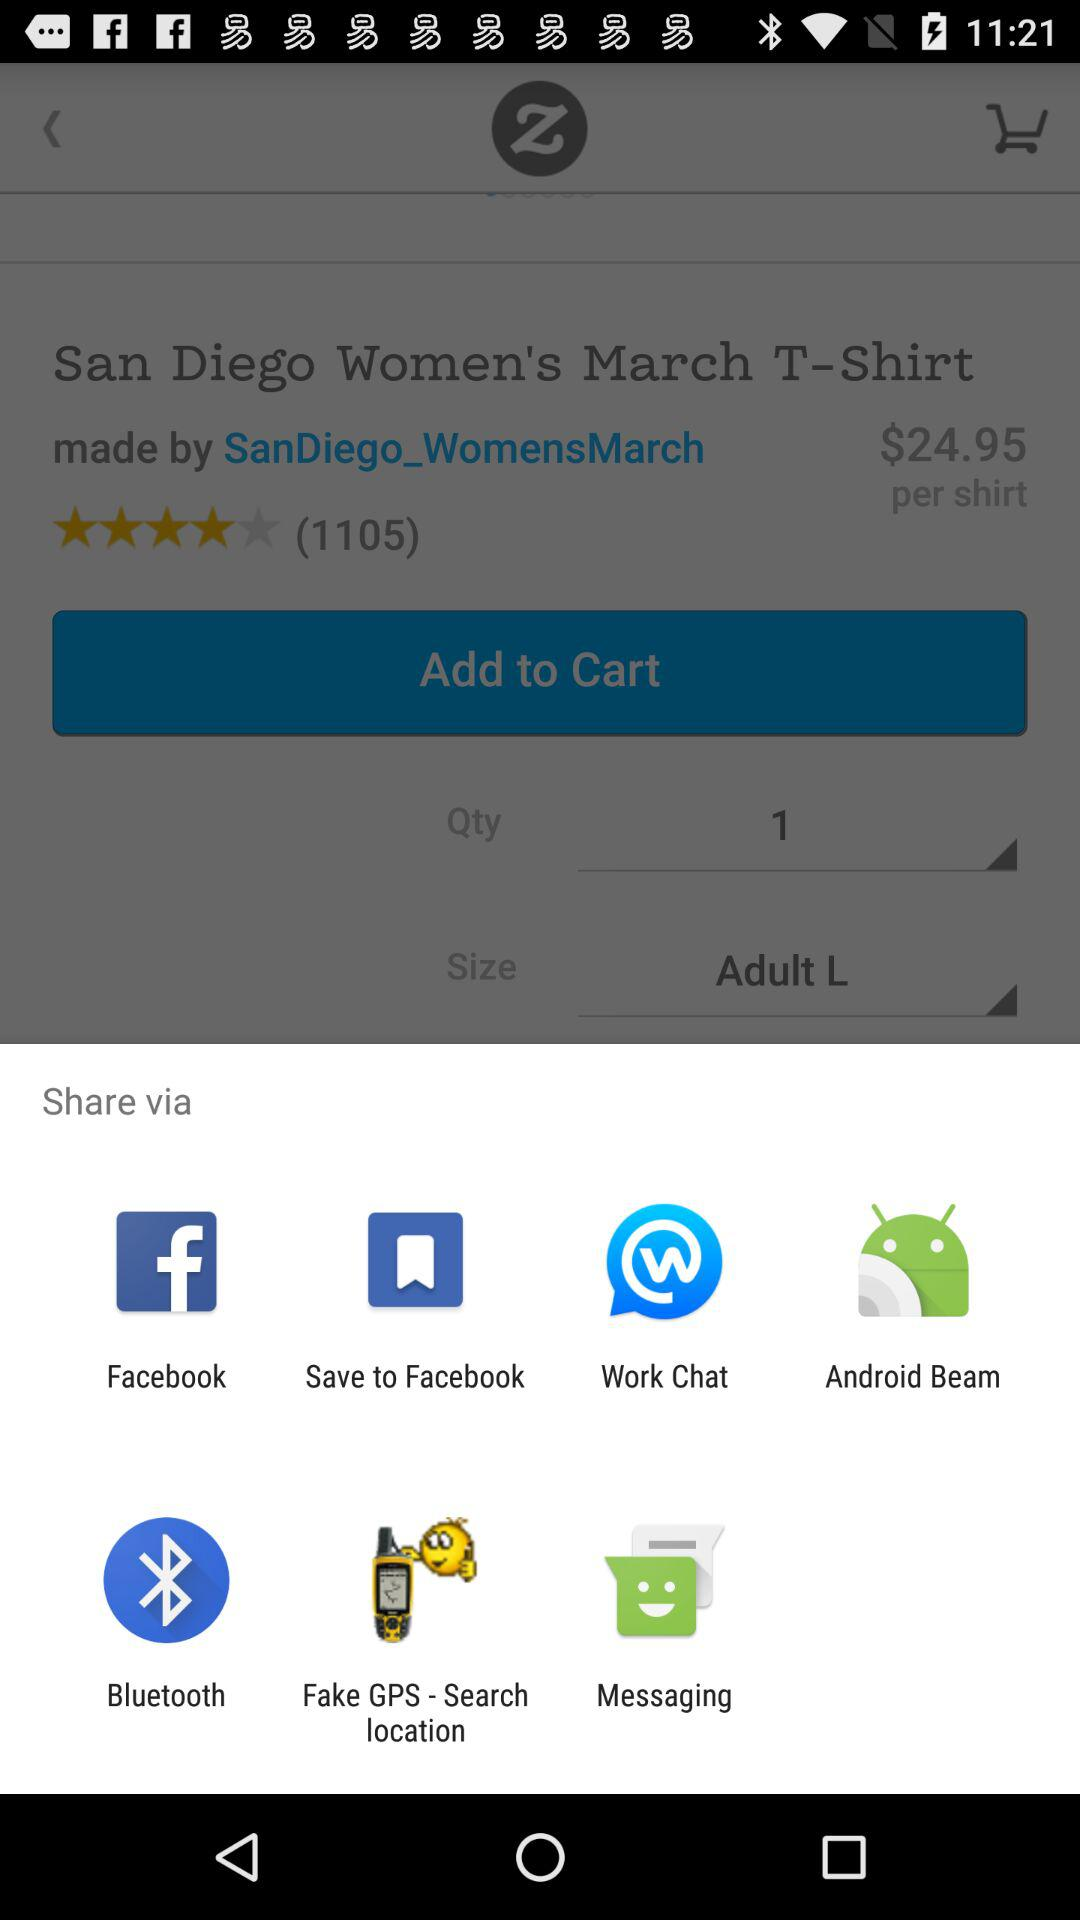What applications can we use to share? You can share it through "Facebook", "Save to Facebook", "Work Chat", "Android Beam", "Bluetooth", "Fake GPS - Search location", and "Messaging". 